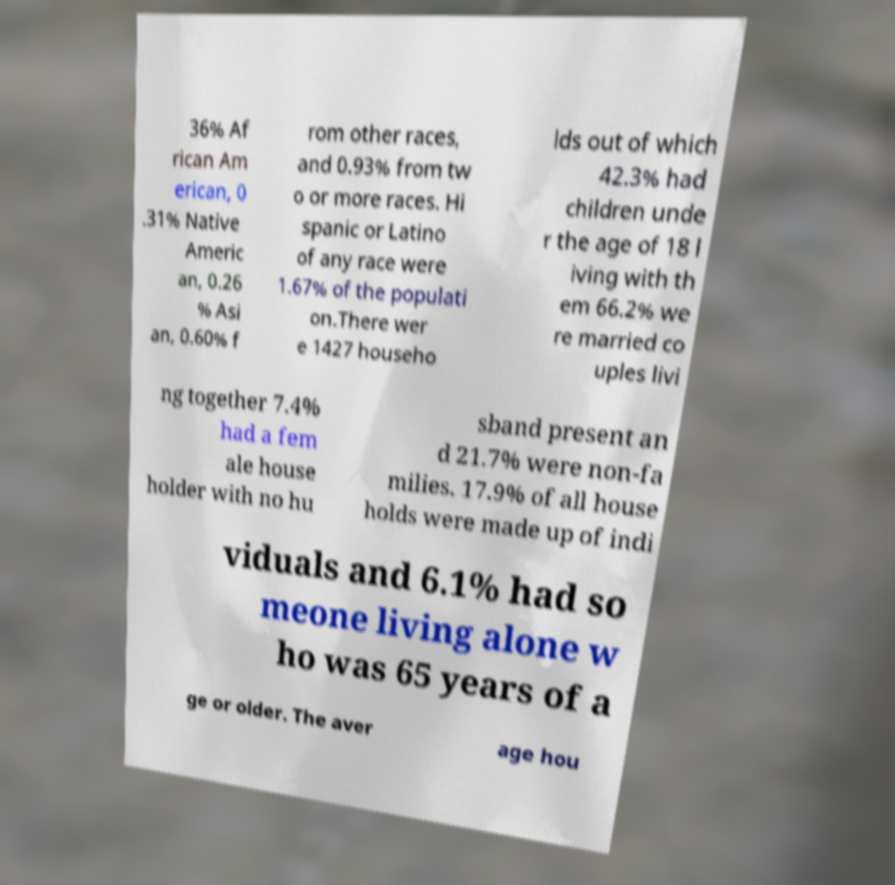Please read and relay the text visible in this image. What does it say? 36% Af rican Am erican, 0 .31% Native Americ an, 0.26 % Asi an, 0.60% f rom other races, and 0.93% from tw o or more races. Hi spanic or Latino of any race were 1.67% of the populati on.There wer e 1427 househo lds out of which 42.3% had children unde r the age of 18 l iving with th em 66.2% we re married co uples livi ng together 7.4% had a fem ale house holder with no hu sband present an d 21.7% were non-fa milies. 17.9% of all house holds were made up of indi viduals and 6.1% had so meone living alone w ho was 65 years of a ge or older. The aver age hou 